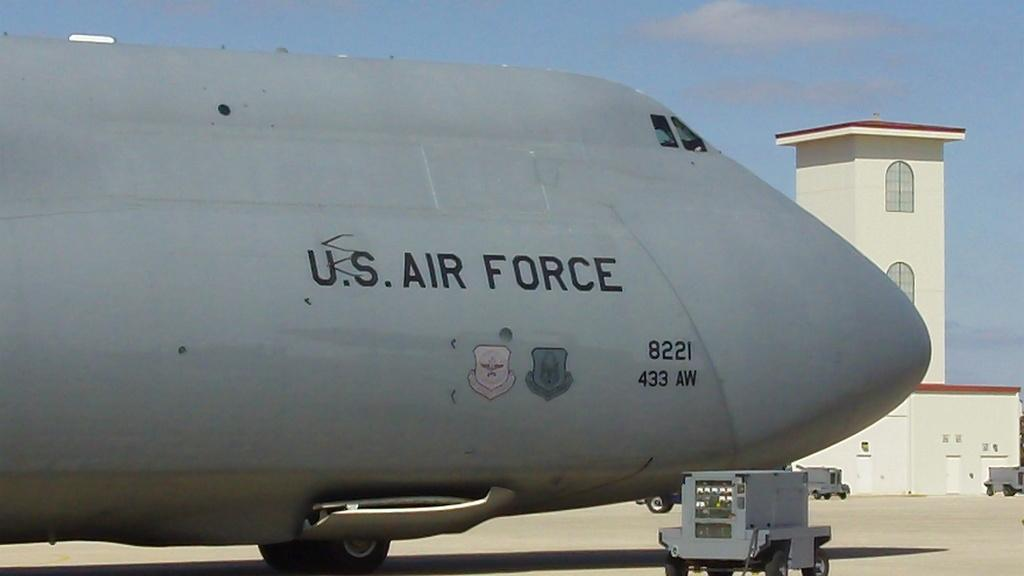What is the main subject of the image? The main subject of the image is an airplane. What structure can be seen on the right side of the image? There is a building on the right side of the image. What is visible at the top of the image? The sky is visible at the top of the image. How many pets are visible in the image? There are no pets present in the image. What type of gate is featured in the image? There is no gate present in the image. 